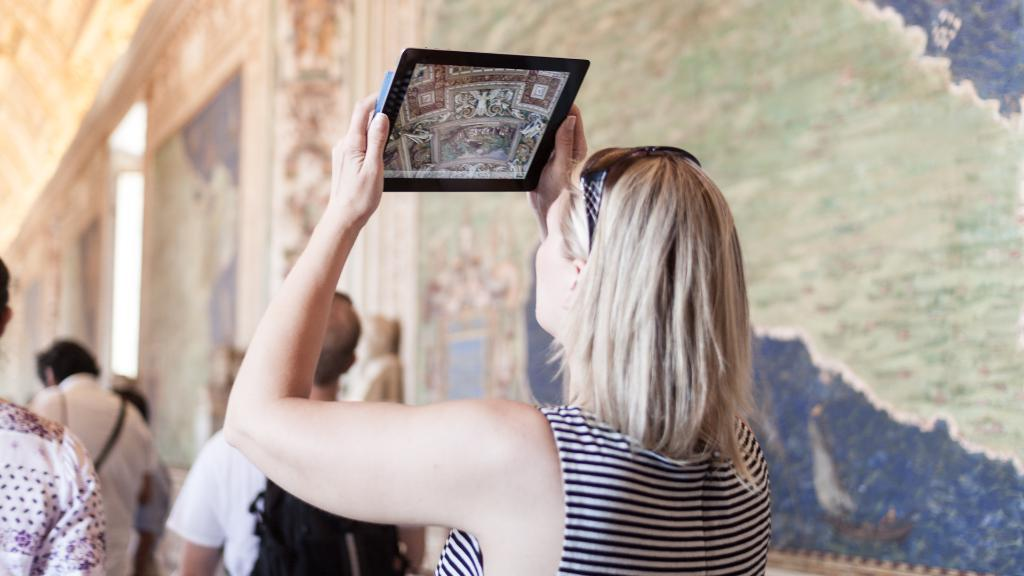Who is the main subject in the image? There is a lady in the center of the image. What is the lady holding in her hands? The lady is holding a tab in her hands. Are there any other people visible in the image? Yes, there are other people in front of the lady. Can you describe the background of the image? There are designed walls in the image. What type of seed can be seen growing on the lady's face in the image? There is no seed or growth on the lady's face in the image. 